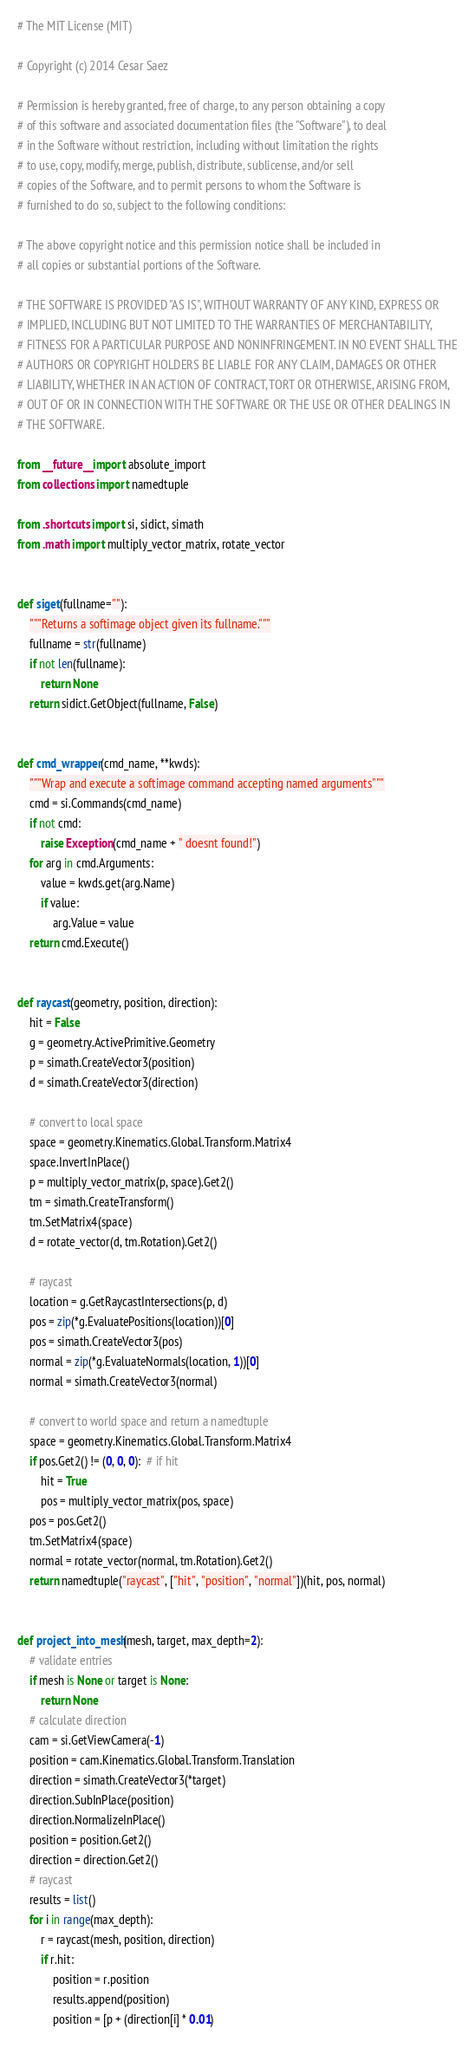Convert code to text. <code><loc_0><loc_0><loc_500><loc_500><_Python_># The MIT License (MIT)

# Copyright (c) 2014 Cesar Saez

# Permission is hereby granted, free of charge, to any person obtaining a copy
# of this software and associated documentation files (the "Software"), to deal
# in the Software without restriction, including without limitation the rights
# to use, copy, modify, merge, publish, distribute, sublicense, and/or sell
# copies of the Software, and to permit persons to whom the Software is
# furnished to do so, subject to the following conditions:

# The above copyright notice and this permission notice shall be included in
# all copies or substantial portions of the Software.

# THE SOFTWARE IS PROVIDED "AS IS", WITHOUT WARRANTY OF ANY KIND, EXPRESS OR
# IMPLIED, INCLUDING BUT NOT LIMITED TO THE WARRANTIES OF MERCHANTABILITY,
# FITNESS FOR A PARTICULAR PURPOSE AND NONINFRINGEMENT. IN NO EVENT SHALL THE
# AUTHORS OR COPYRIGHT HOLDERS BE LIABLE FOR ANY CLAIM, DAMAGES OR OTHER
# LIABILITY, WHETHER IN AN ACTION OF CONTRACT, TORT OR OTHERWISE, ARISING FROM,
# OUT OF OR IN CONNECTION WITH THE SOFTWARE OR THE USE OR OTHER DEALINGS IN
# THE SOFTWARE.

from __future__ import absolute_import
from collections import namedtuple

from .shortcuts import si, sidict, simath
from .math import multiply_vector_matrix, rotate_vector


def siget(fullname=""):
    """Returns a softimage object given its fullname."""
    fullname = str(fullname)
    if not len(fullname):
        return None
    return sidict.GetObject(fullname, False)


def cmd_wrapper(cmd_name, **kwds):
    """Wrap and execute a softimage command accepting named arguments"""
    cmd = si.Commands(cmd_name)
    if not cmd:
        raise Exception(cmd_name + " doesnt found!")
    for arg in cmd.Arguments:
        value = kwds.get(arg.Name)
        if value:
            arg.Value = value
    return cmd.Execute()


def raycast(geometry, position, direction):
    hit = False
    g = geometry.ActivePrimitive.Geometry
    p = simath.CreateVector3(position)
    d = simath.CreateVector3(direction)

    # convert to local space
    space = geometry.Kinematics.Global.Transform.Matrix4
    space.InvertInPlace()
    p = multiply_vector_matrix(p, space).Get2()
    tm = simath.CreateTransform()
    tm.SetMatrix4(space)
    d = rotate_vector(d, tm.Rotation).Get2()

    # raycast
    location = g.GetRaycastIntersections(p, d)
    pos = zip(*g.EvaluatePositions(location))[0]
    pos = simath.CreateVector3(pos)
    normal = zip(*g.EvaluateNormals(location, 1))[0]
    normal = simath.CreateVector3(normal)

    # convert to world space and return a namedtuple
    space = geometry.Kinematics.Global.Transform.Matrix4
    if pos.Get2() != (0, 0, 0):  # if hit
        hit = True
        pos = multiply_vector_matrix(pos, space)
    pos = pos.Get2()
    tm.SetMatrix4(space)
    normal = rotate_vector(normal, tm.Rotation).Get2()
    return namedtuple("raycast", ["hit", "position", "normal"])(hit, pos, normal)


def project_into_mesh(mesh, target, max_depth=2):
    # validate entries
    if mesh is None or target is None:
        return None
    # calculate direction
    cam = si.GetViewCamera(-1)
    position = cam.Kinematics.Global.Transform.Translation
    direction = simath.CreateVector3(*target)
    direction.SubInPlace(position)
    direction.NormalizeInPlace()
    position = position.Get2()
    direction = direction.Get2()
    # raycast
    results = list()
    for i in range(max_depth):
        r = raycast(mesh, position, direction)
        if r.hit:
            position = r.position
            results.append(position)
            position = [p + (direction[i] * 0.01)</code> 